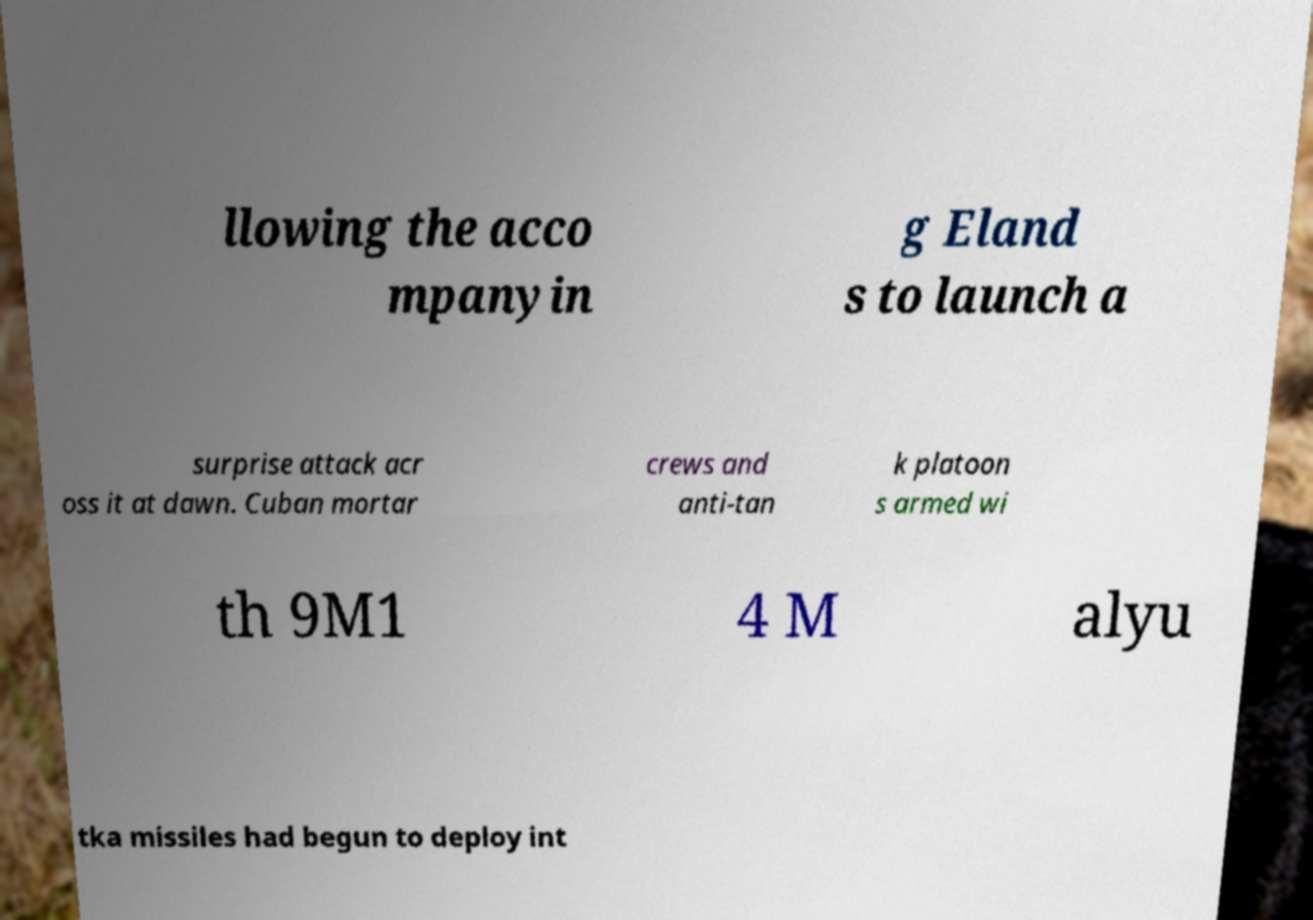There's text embedded in this image that I need extracted. Can you transcribe it verbatim? llowing the acco mpanyin g Eland s to launch a surprise attack acr oss it at dawn. Cuban mortar crews and anti-tan k platoon s armed wi th 9M1 4 M alyu tka missiles had begun to deploy int 